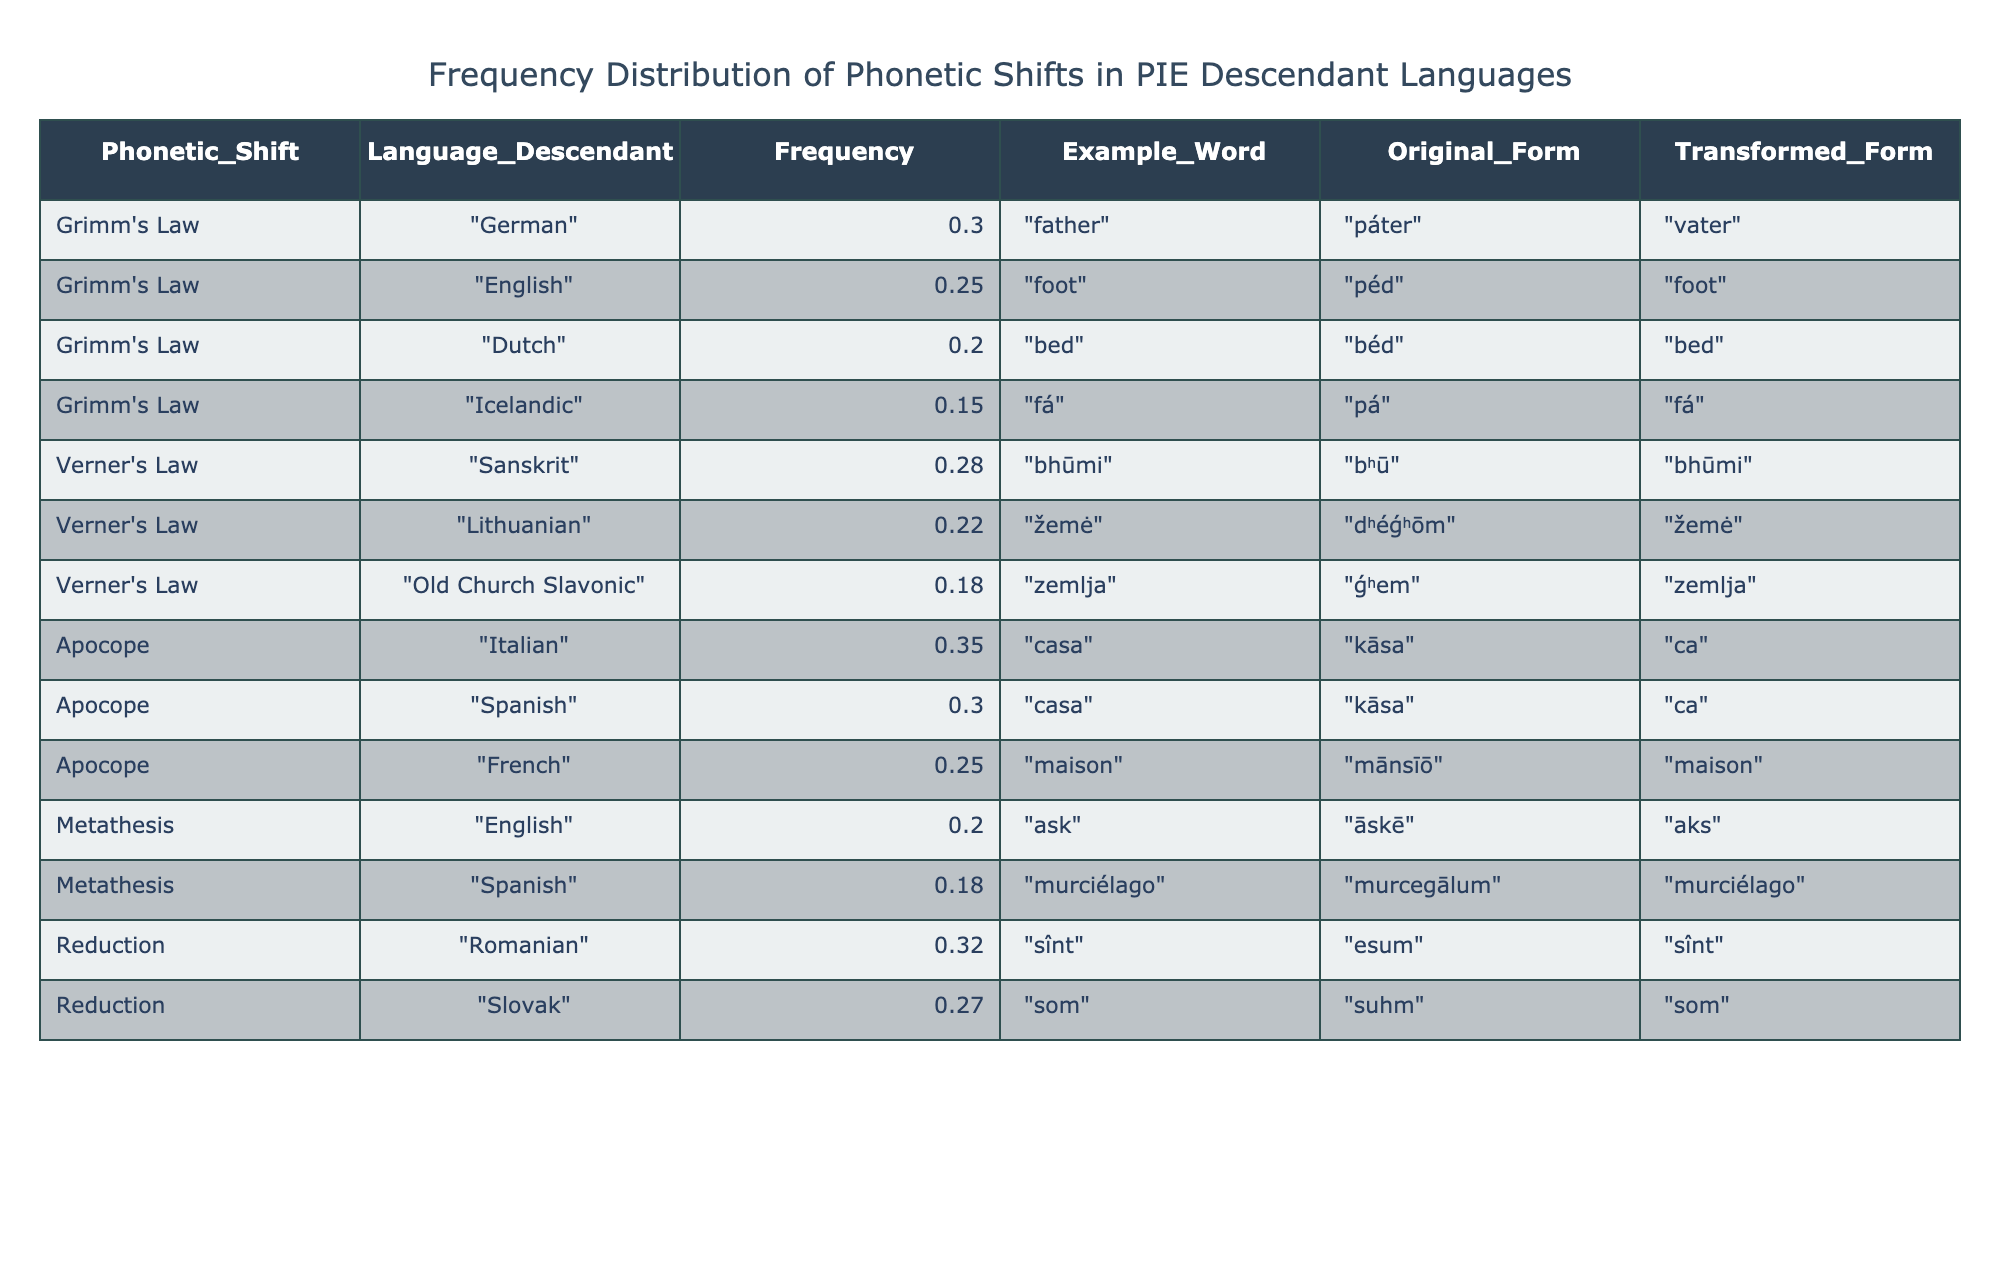What phonetic shift has the highest frequency in descendant languages? The maximum frequency in the table is 0.35, which corresponds to "Apocope" in "Italian."
Answer: Apocope Which language under "Grimm's Law" has the lowest frequency? By looking at the frequencies listed for languages under "Grimm's Law," "Icelandic" has the lowest frequency at 0.15.
Answer: Icelandic What is the average frequency of phonetic shifts for languages under "Verner's Law"? The frequencies for "Verner's Law" are 0.28 (Sanskrit), 0.22 (Lithuanian), and 0.18 (Old Church Slavonic). To find the average, sum these values: 0.28 + 0.22 + 0.18 = 0.68, and then divide by 3. So, 0.68 / 3 = approximately 0.227.
Answer: 0.227 Does "Spanish" show evidence of both "Apocope" and "Metathesis"? The table indicates that "Spanish" is listed under "Apocope" with a frequency of 0.30. However, it is also included under "Metathesis" with a frequency of 0.18. Thus, "Spanish" does exhibit evidence of both phonetic shifts.
Answer: Yes Which phonetic shift has more frequencies above 0.25, and how many languages does it apply to? Upon review, "Grimm's Law" has three frequencies above 0.25 (German, English, Dutch), while "Apocope" has three as well (Italian, Spanish, French). To conclude, both shifts have three languages with frequencies greater than 0.25.
Answer: Three for each What is the frequency difference between the highest and lowest languages under "Reduction"? The frequencies listed under "Reduction" are 0.32 (Romanian) and 0.27 (Slovak). To find the difference, subtract the lowest frequency from the highest: 0.32 - 0.27 = 0.05.
Answer: 0.05 Which language transformation gives the example word "father" and what is its original form? The example word "father" corresponds to "German" under "Grimm's Law," with the original form being "páter."
Answer: German, páter Is the frequency of "Metathesis" higher in "Spanish" than in "English"? The frequency for "Metathesis" in "Spanish" is 0.18 and in "English," it is 0.20. Since 0.18 is less than 0.20, it is clear that "Metathesis" has a lower frequency in "Spanish" compared to "English."
Answer: No 